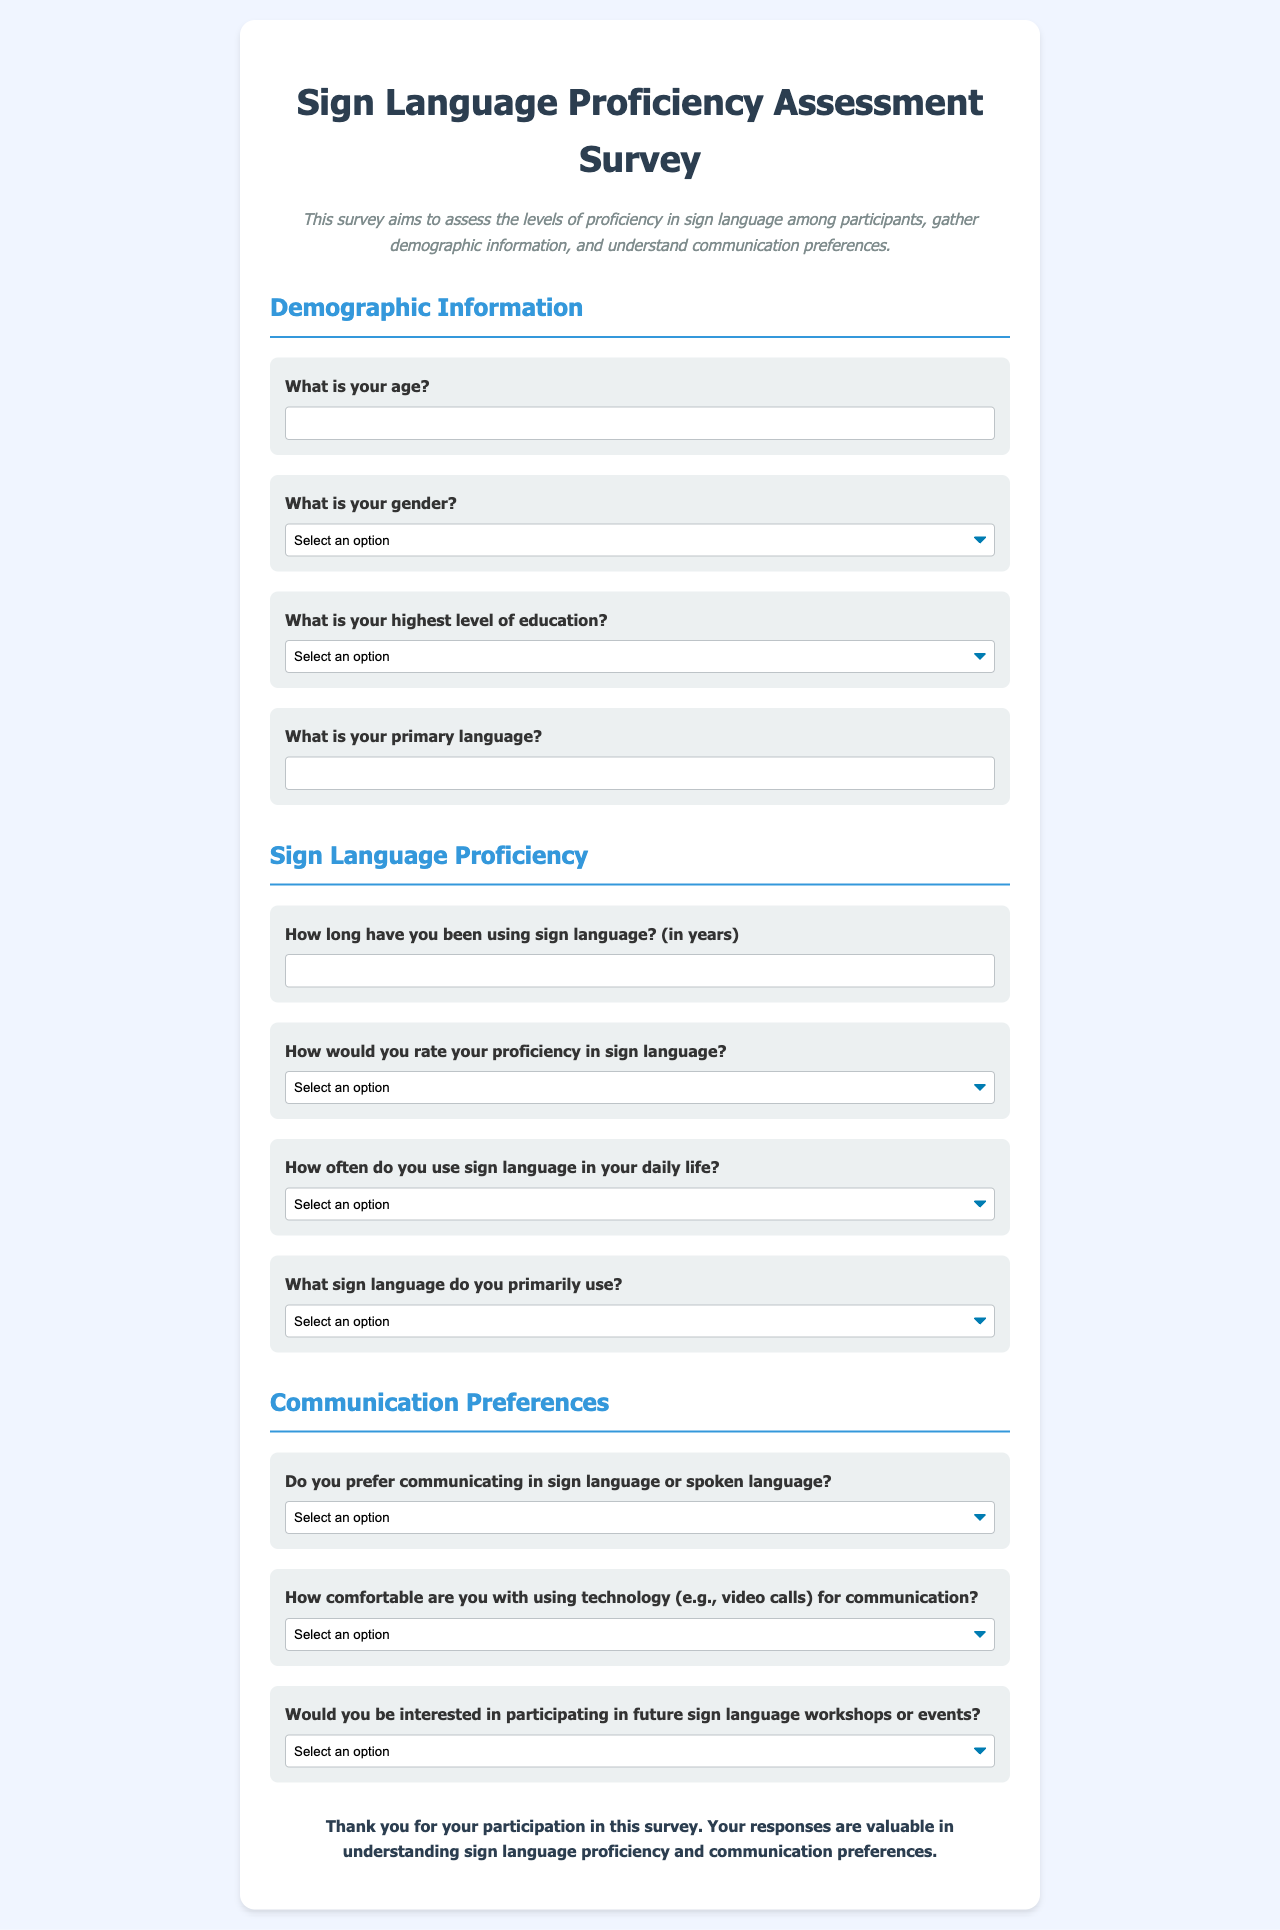What is the title of the survey? The title of the survey is stated prominently at the top of the document.
Answer: Sign Language Proficiency Assessment Survey What is the required age input format? The age input is specified as a numerical value that participants must enter.
Answer: Number What options are available for gender selection? The gender selection includes multiple options listed in a dropdown menu in the form.
Answer: Male, Female, Non-binary, Prefer not to say How long is the experience input for sign language in years? Participants are asked to provide the duration of their sign language experience in numerical format, indicating it is in years.
Answer: Number What is the highest education level option available? The survey asks about the highest educational achievement of the participants.
Answer: High School Diploma, Associate Degree, Bachelor's Degree, Master's Degree, Doctorate, Other Which sign language is primarily used by participants? Participants are asked to select their primary sign language from a list of available options in a dropdown menu.
Answer: American Sign Language (ASL), British Sign Language (BSL), Langue des Signes Française (LSF), Other What is the question about communication preference? The document asks participants to specify their preferred mode of communication regarding spoken or sign language.
Answer: Do you prefer communicating in sign language or spoken language? How comfortable are participants with technology for communication? The survey includes a question regarding participants' comfort levels with technological communication methods.
Answer: Very comfortable, Somewhat comfortable, Neutral, Somewhat uncomfortable, Very uncomfortable 